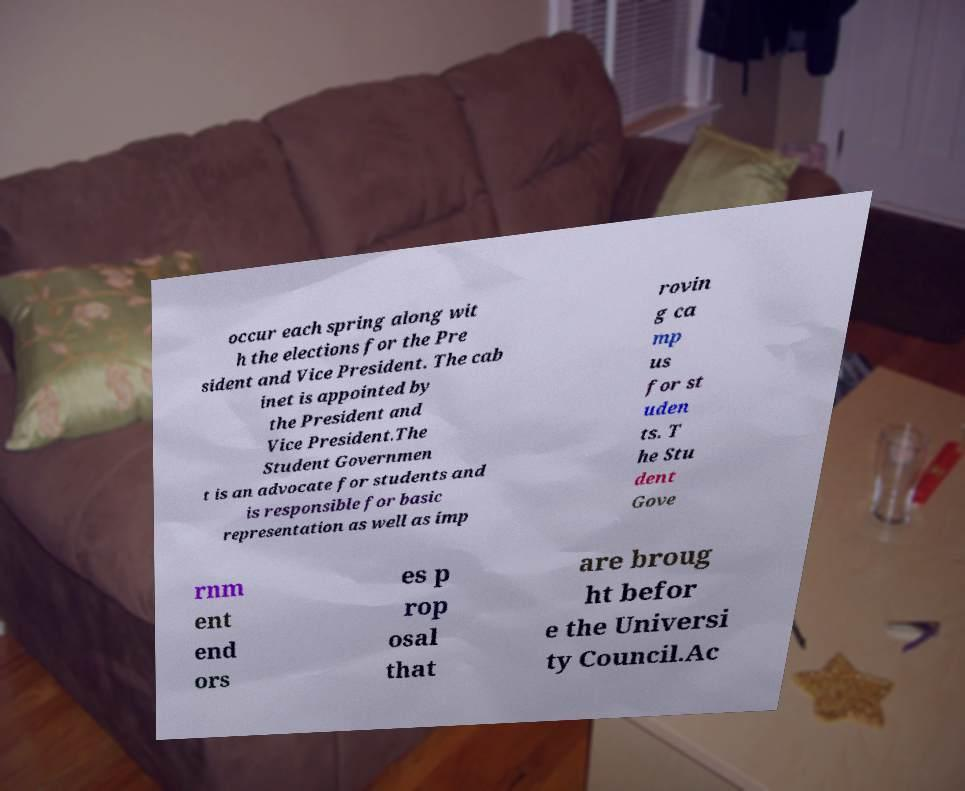Could you extract and type out the text from this image? occur each spring along wit h the elections for the Pre sident and Vice President. The cab inet is appointed by the President and Vice President.The Student Governmen t is an advocate for students and is responsible for basic representation as well as imp rovin g ca mp us for st uden ts. T he Stu dent Gove rnm ent end ors es p rop osal that are broug ht befor e the Universi ty Council.Ac 